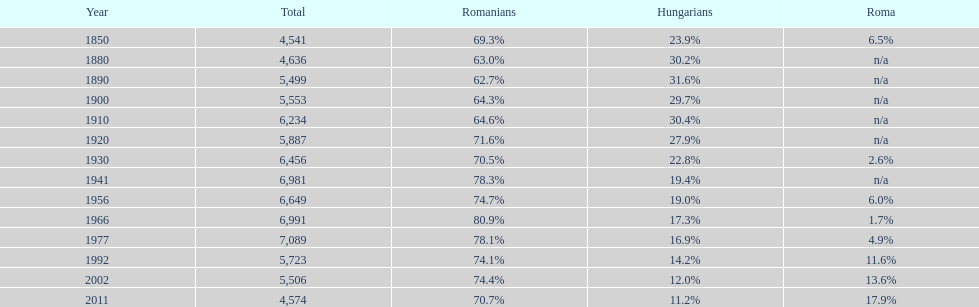In which year did the year with 7 1977. 